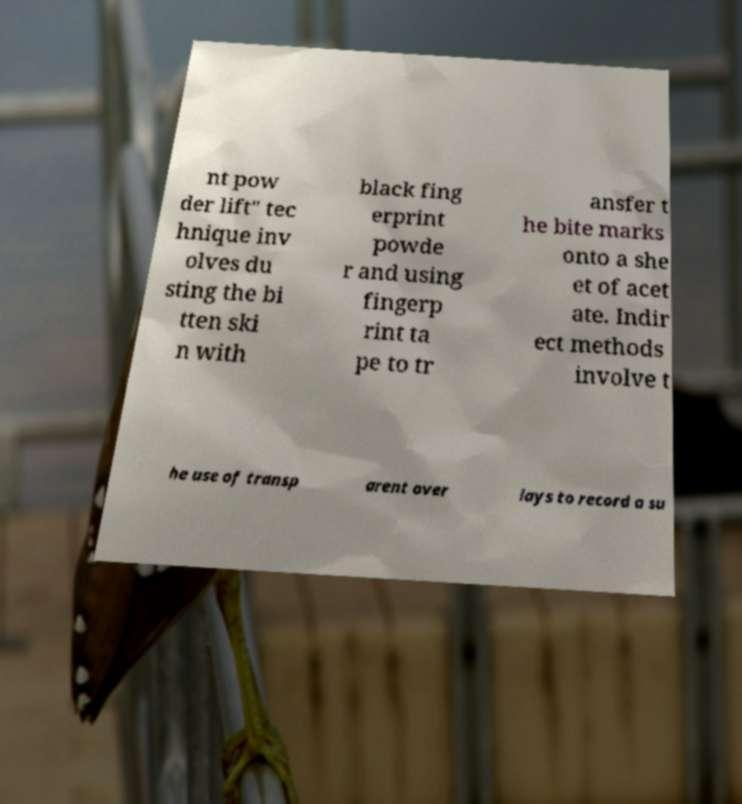For documentation purposes, I need the text within this image transcribed. Could you provide that? nt pow der lift" tec hnique inv olves du sting the bi tten ski n with black fing erprint powde r and using fingerp rint ta pe to tr ansfer t he bite marks onto a she et of acet ate. Indir ect methods involve t he use of transp arent over lays to record a su 